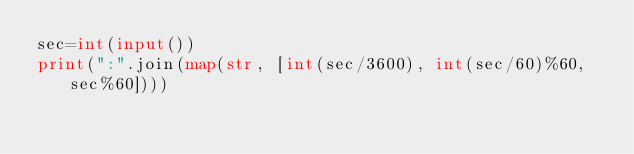<code> <loc_0><loc_0><loc_500><loc_500><_Python_>sec=int(input())
print(":".join(map(str, [int(sec/3600), int(sec/60)%60, sec%60])))</code> 